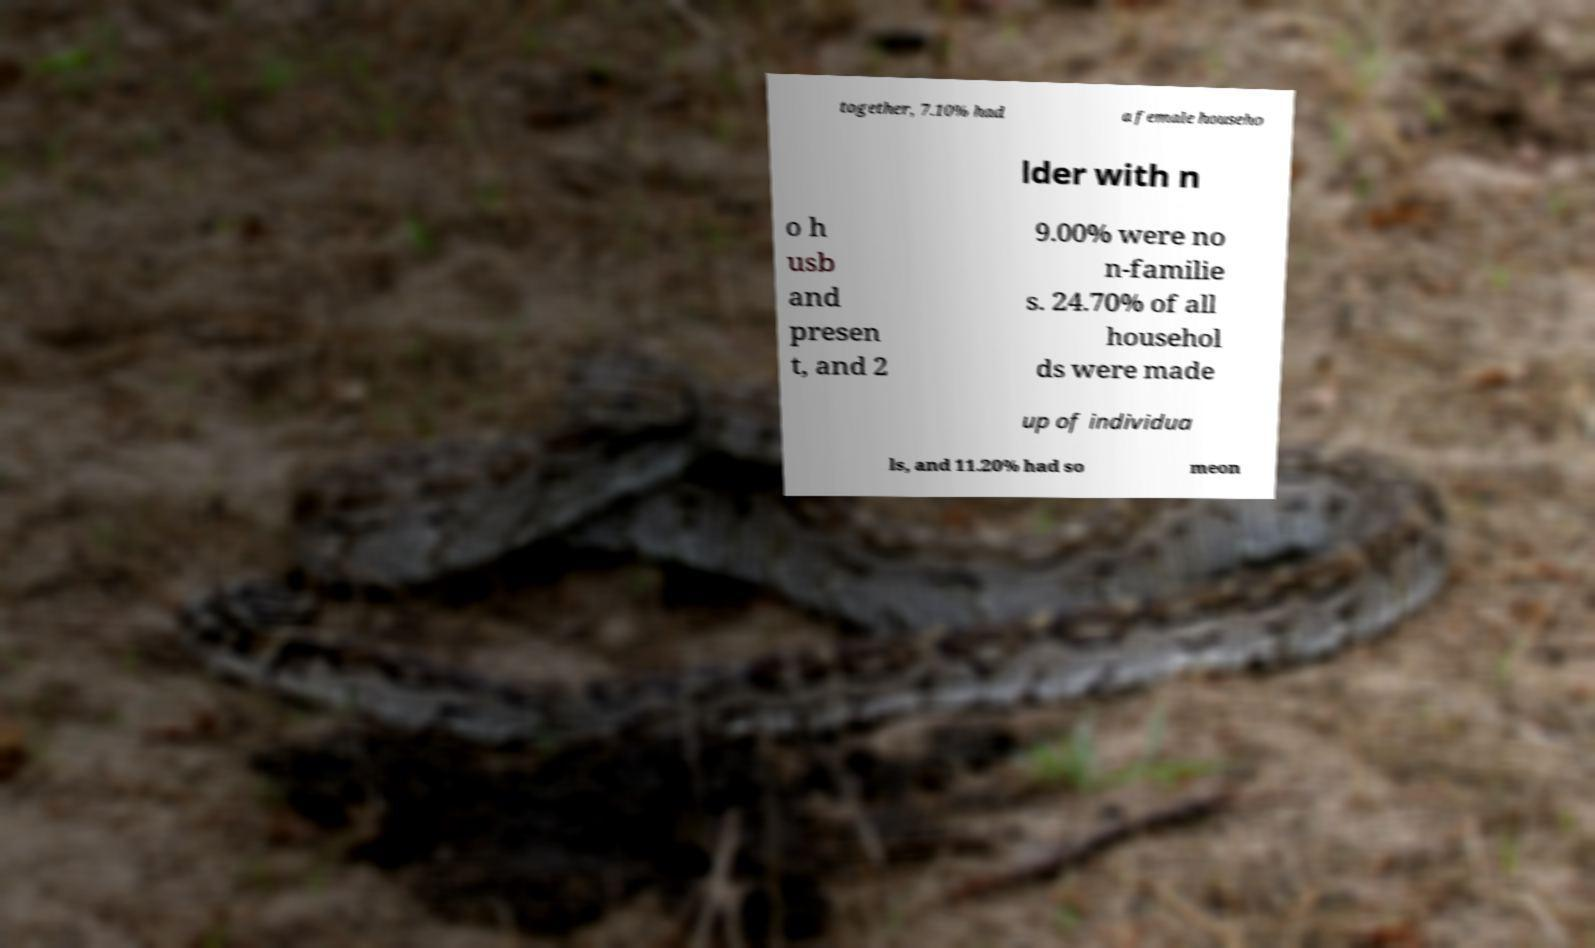Could you extract and type out the text from this image? together, 7.10% had a female househo lder with n o h usb and presen t, and 2 9.00% were no n-familie s. 24.70% of all househol ds were made up of individua ls, and 11.20% had so meon 